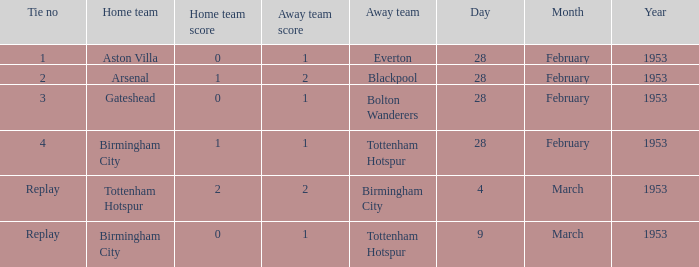Which Home team has a Score of 0–1, and an Away team of tottenham hotspur? Birmingham City. 